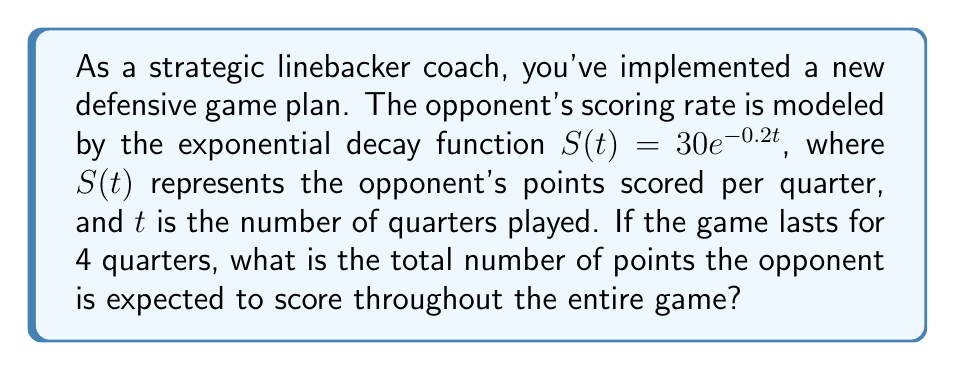Could you help me with this problem? To solve this problem, we need to integrate the scoring rate function over the duration of the game. Here's the step-by-step process:

1) The scoring rate function is given by $S(t) = 30e^{-0.2t}$.

2) To find the total points scored, we need to calculate the definite integral of this function from $t=0$ to $t=4$ (representing 4 quarters):

   $$\text{Total Points} = \int_0^4 30e^{-0.2t} dt$$

3) To integrate this, we can use the following rule: $\int e^{ax} dx = \frac{1}{a}e^{ax} + C$

4) Applying this rule to our integral:

   $$\text{Total Points} = -\frac{30}{0.2}[e^{-0.2t}]_0^4$$

5) Evaluating the integral:

   $$\text{Total Points} = -150[e^{-0.2(4)} - e^{-0.2(0)}]$$
   $$= -150[e^{-0.8} - 1]$$

6) Calculating the exponential:

   $$= -150[0.4493 - 1]$$
   $$= -150[-0.5507]$$
   $$= 82.605$$

7) Rounding to the nearest whole number (as fractional points aren't awarded in most sports):

   $$\text{Total Points} \approx 83$$

This result shows that with your new defensive strategy, the opponent is expected to score approximately 83 points over the course of the game.
Answer: 83 points 